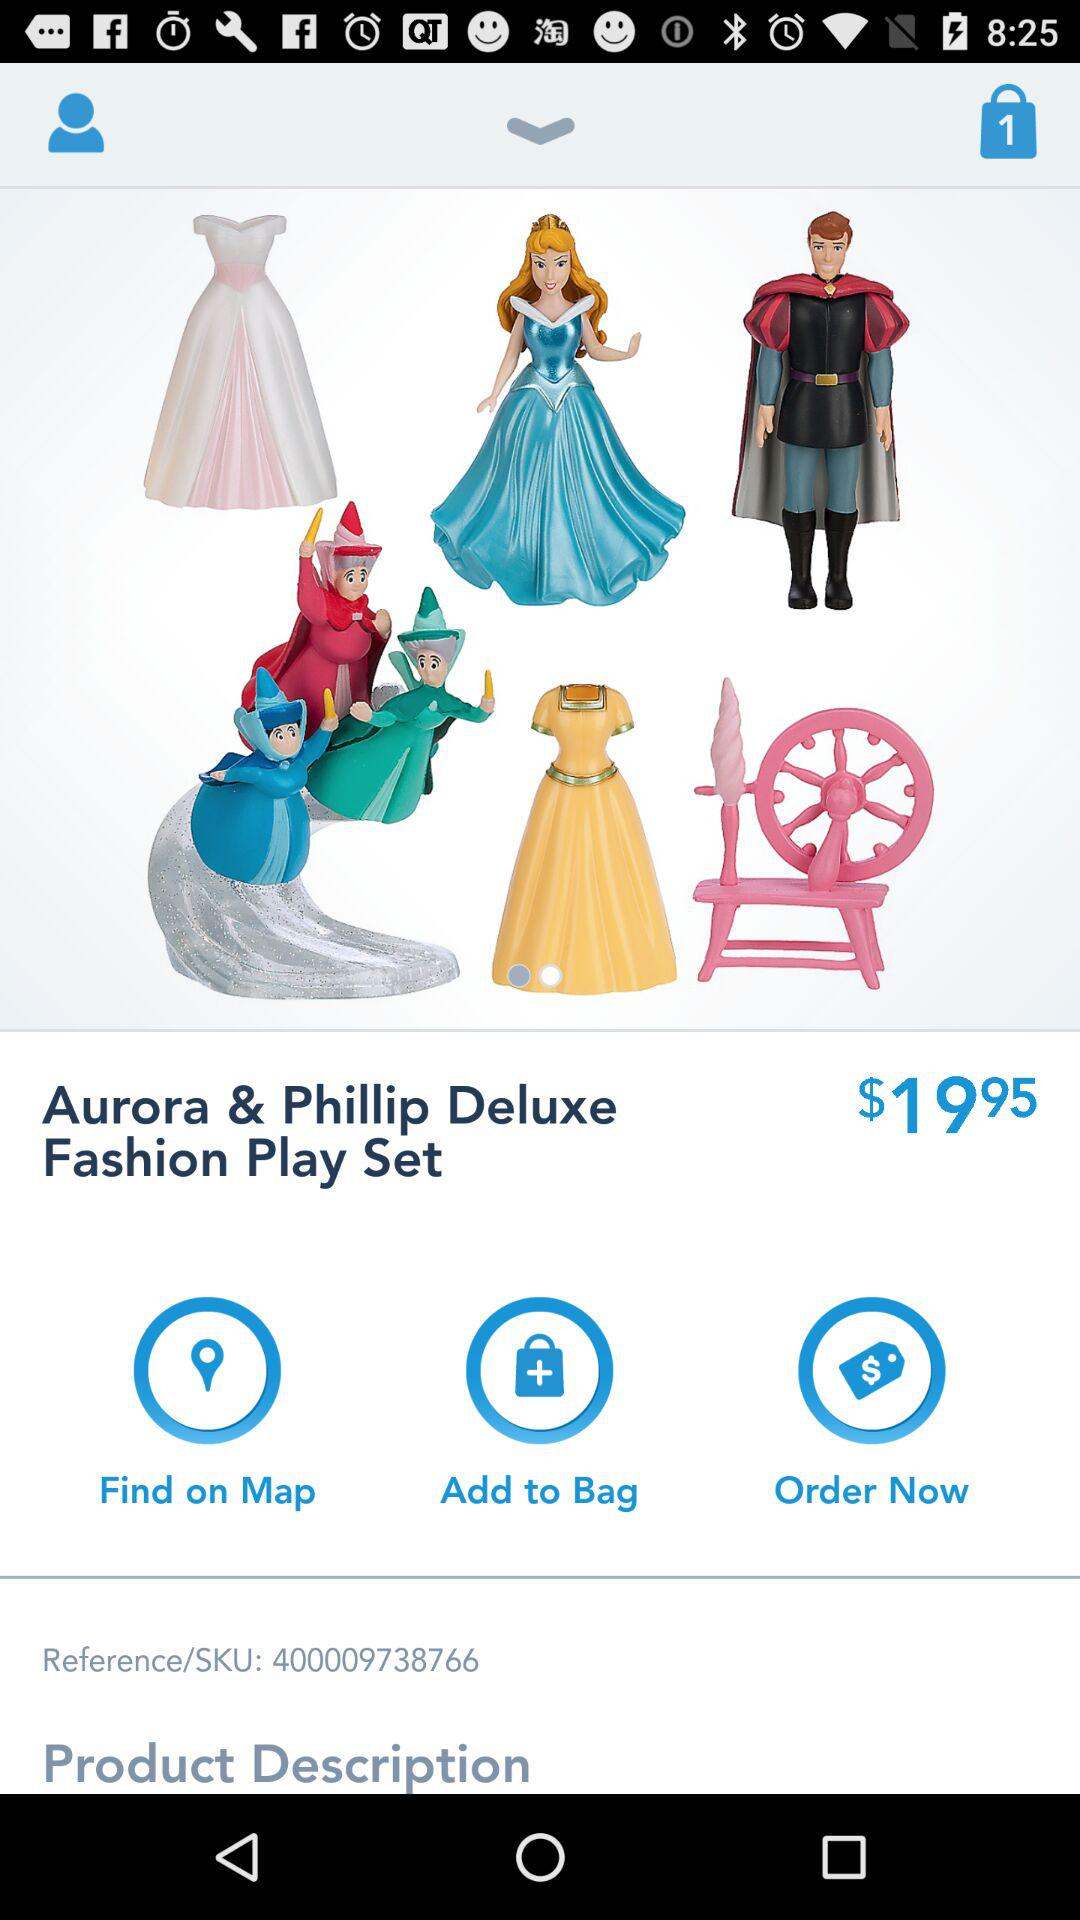How many items are in the bag?
When the provided information is insufficient, respond with <no answer>. <no answer> 